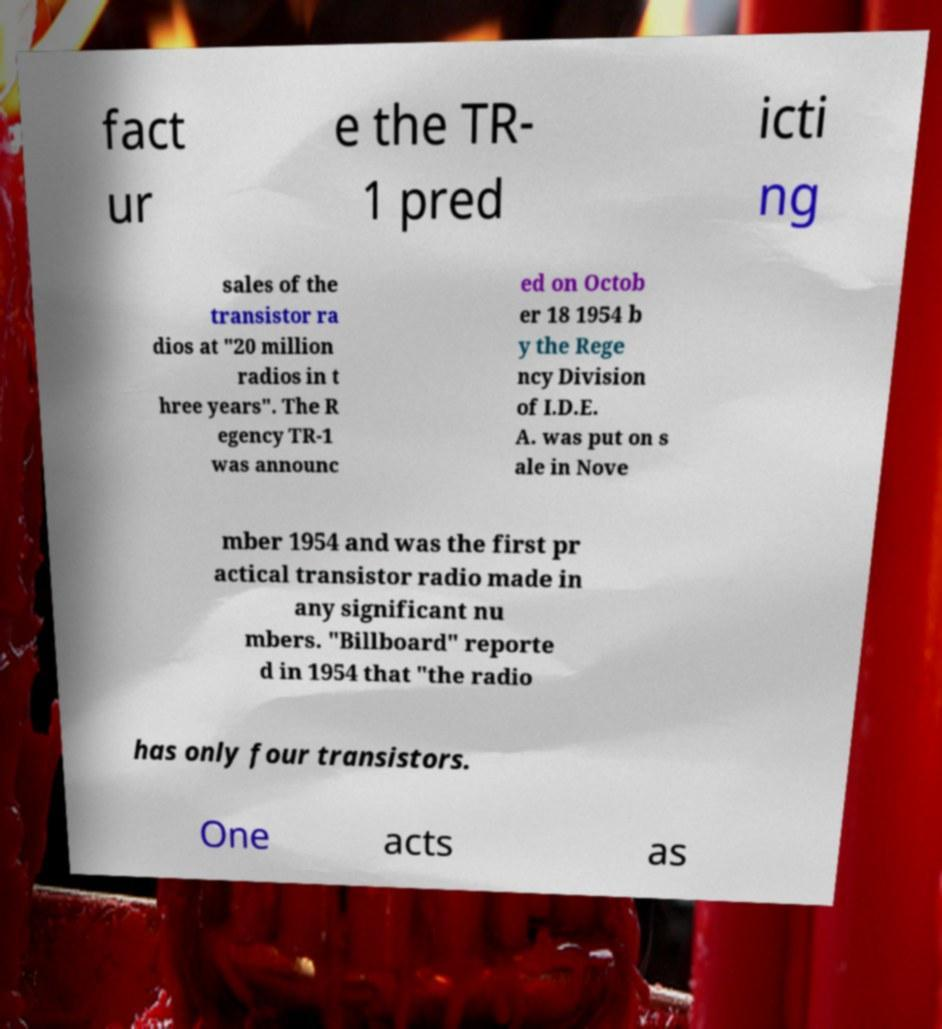What messages or text are displayed in this image? I need them in a readable, typed format. fact ur e the TR- 1 pred icti ng sales of the transistor ra dios at "20 million radios in t hree years". The R egency TR-1 was announc ed on Octob er 18 1954 b y the Rege ncy Division of I.D.E. A. was put on s ale in Nove mber 1954 and was the first pr actical transistor radio made in any significant nu mbers. "Billboard" reporte d in 1954 that "the radio has only four transistors. One acts as 